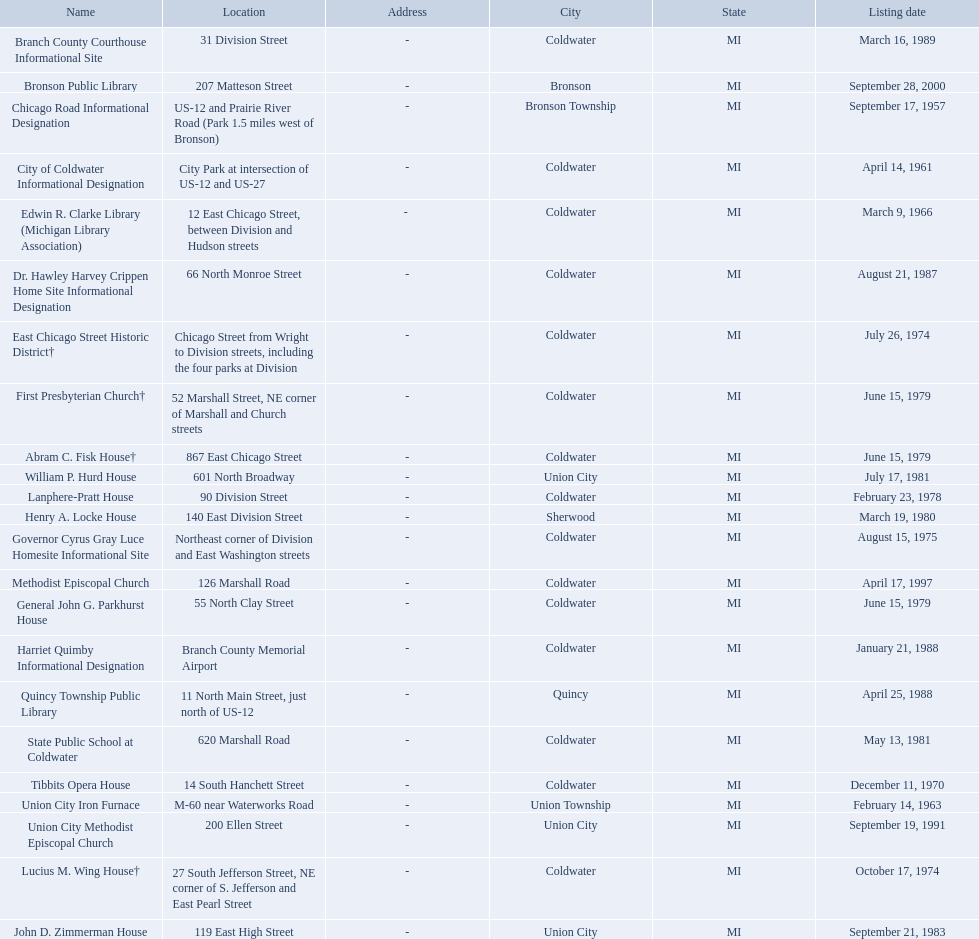In branch co. mi what historic sites are located on a near a highway? Chicago Road Informational Designation, City of Coldwater Informational Designation, Quincy Township Public Library, Union City Iron Furnace. Of the historic sites ins branch co. near highways, which ones are near only us highways? Chicago Road Informational Designation, City of Coldwater Informational Designation, Quincy Township Public Library. Which historical sites in branch co. are near only us highways and are not a building? Chicago Road Informational Designation, City of Coldwater Informational Designation. Which non-building historical sites in branch county near a us highways is closest to bronson? Chicago Road Informational Designation. 